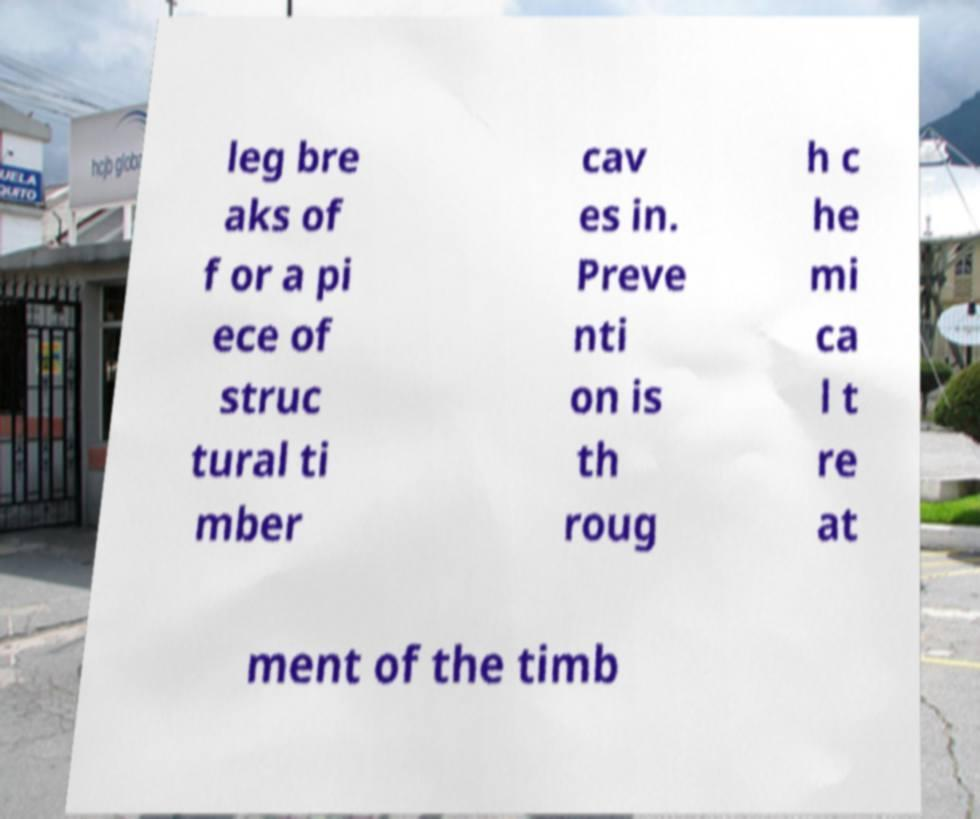I need the written content from this picture converted into text. Can you do that? leg bre aks of f or a pi ece of struc tural ti mber cav es in. Preve nti on is th roug h c he mi ca l t re at ment of the timb 